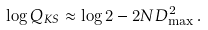Convert formula to latex. <formula><loc_0><loc_0><loc_500><loc_500>\log Q _ { K S } \approx \log 2 - 2 N D _ { \max } ^ { 2 } \, .</formula> 